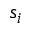Convert formula to latex. <formula><loc_0><loc_0><loc_500><loc_500>s _ { i }</formula> 